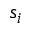Convert formula to latex. <formula><loc_0><loc_0><loc_500><loc_500>s _ { i }</formula> 